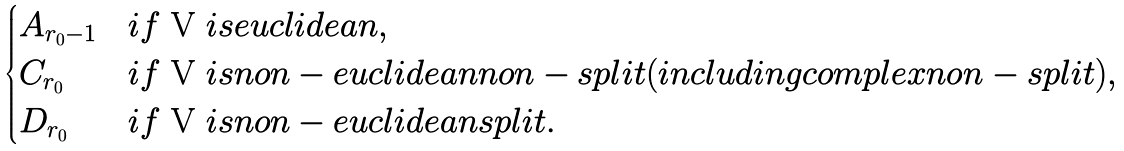Convert formula to latex. <formula><loc_0><loc_0><loc_500><loc_500>\begin{cases} A _ { r _ { 0 } - 1 } & i f $ V $ i s e u c l i d e a n , \\ C _ { r _ { 0 } } & i f $ V $ i s n o n - e u c l i d e a n n o n - s p l i t ( i n c l u d i n g c o m p l e x n o n - s p l i t ) , \\ D _ { r _ { 0 } } & i f $ V $ i s n o n - e u c l i d e a n s p l i t . \end{cases}</formula> 